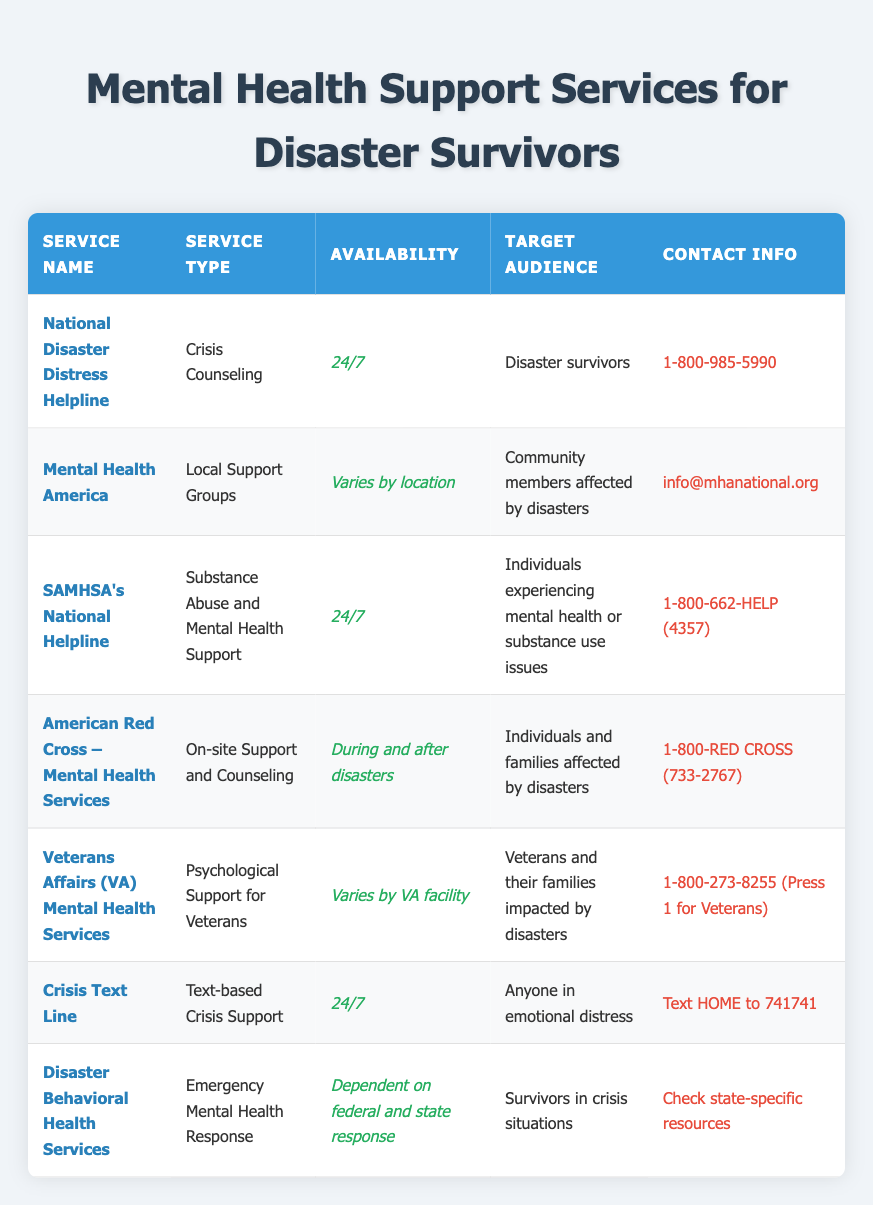What type of service does the National Disaster Distress Helpline provide? The table lists "Crisis Counseling" as the service type for the National Disaster Distress Helpline.
Answer: Crisis Counseling How many services are available 24/7? By checking the availability column, three services are noted as available 24/7: the National Disaster Distress Helpline, SAMHSA's National Helpline, and the Crisis Text Line.
Answer: 3 Is the American Red Cross Mental Health Services available during disasters? Yes, according to the table, the availability is specifically noted as "During and after disasters".
Answer: Yes For whom does the Veterans Affairs Mental Health Services provide psychological support? The table specifies that this service targets "Veterans and their families impacted by disasters".
Answer: Veterans and their families What is the contact number for the Crisis Text Line, and what type of support does it offer? The table states that the Crisis Text Line provides "Text-based Crisis Support" and the contact method is to text HOME to 741741.
Answer: Text HOME to 741741 How does the availability of Disaster Behavioral Health Services depend on federal and state response? The table indicates that this service's availability is variable based on federal and state responses, meaning it is not available consistently and depends on specific circumstances surrounding disasters.
Answer: It is dependent on federal and state response Which service provides on-site support and counseling for individuals affected by disasters? The American Red Cross – Mental Health Services offers on-site support and counseling and is specifically aimed at individuals and families affected by disasters.
Answer: American Red Cross – Mental Health Services Are there services listed that specifically target community members affected by disasters? Yes, the table shows that Mental Health America provides Local Support Groups, which are aimed at community members affected by disasters.
Answer: Yes What is the primary focus of SAMHSA's National Helpline? According to the table, SAMHSA's National Helpline focuses on "Substance Abuse and Mental Health Support", addressing issues related to both substance use and mental health.
Answer: Substance Abuse and Mental Health Support 